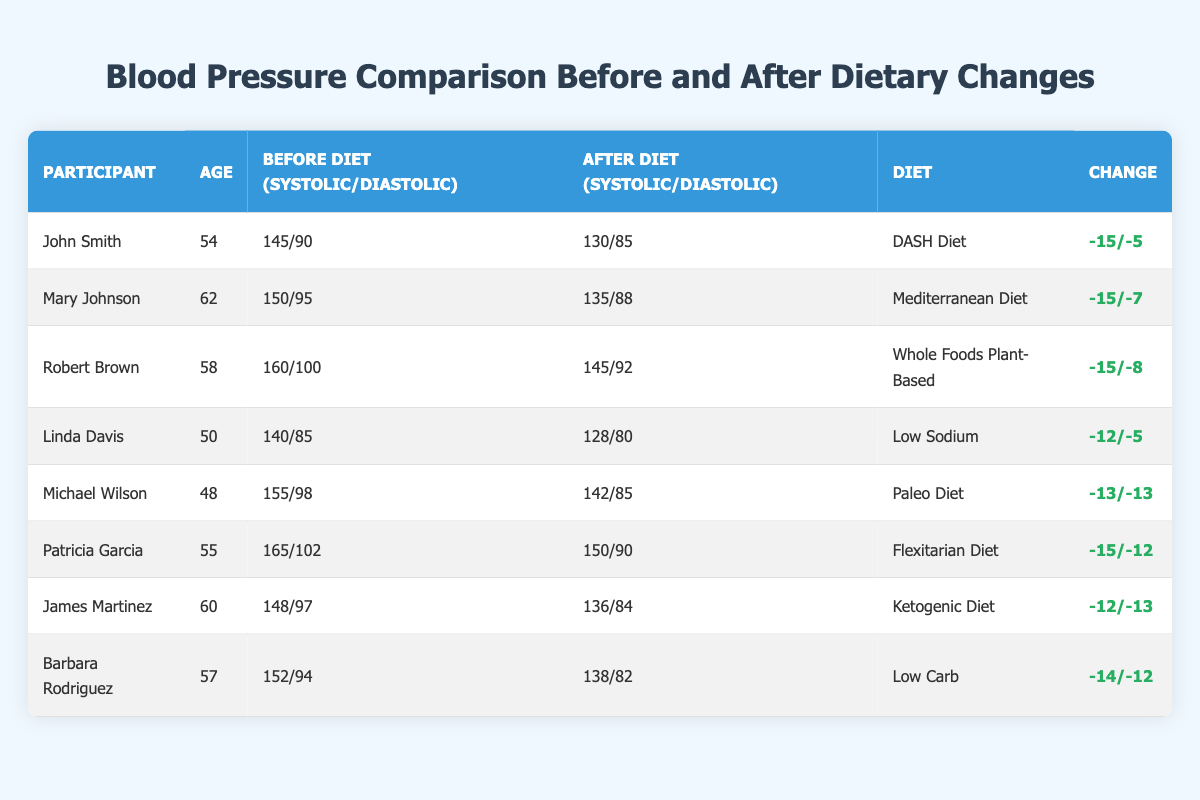What was John Smith's blood pressure before the diet? The table lists John's before diet blood pressure as 145 systolic and 90 diastolic.
Answer: 145/90 Which diet led to the most significant decrease in systolic blood pressure? Robert Brown, on the Whole Foods Plant-Based diet, had a decrease from 160 to 145, which is a change of -15. This decrease is the largest in the table.
Answer: Whole Foods Plant-Based Did Linda Davis experience an improvement in both systolic and diastolic blood pressure? Linda's systolic decreased from 140 to 128 and diastolic from 85 to 80, indicating improvements in both measurements.
Answer: Yes What is the average reduction in diastolic blood pressure for all participants? The diastolic changes are -5, -7, -8, -5, -13, -12, -13, and -12. Summing these gives -60, and dividing by 8 participants results in an average of -7.5.
Answer: -7.5 Which participant had the highest blood pressure after dietary changes? Looking at the "After Diet" column, Patricia Garcia has the highest reading of 150 systolic and 90 diastolic, which is the maximum in that section.
Answer: Patricia Garcia How many participants had a diastolic reading of 85 or higher after the diet? After the diet, 5 participants have diastolic readings of 85 or higher (Patricia, Robert, Michael, James, and Linda).
Answer: 5 What is the total systolic blood pressure reduction among all participants? The systolic reductions are -15, -15, -15, -12, -13, -15, -12, and -14. Summing these gives -111, which represents the total reduction in systolic blood pressure.
Answer: -111 Did any participant have the same diastolic reading before and after the diet? No participant has the same diastolic reading before and after the diet, all showed improvements.
Answer: No Which diet had participants with the lowest average systolic blood pressure after the dietary change? After analyzing the “After Diet” systolic readings, Linda Davis had 128, John Smith 130, and others higher than these, leading to the conclusion that Low Sodium had the lowest average.
Answer: Low Sodium What percentage of participants showed improvement in both systolic and diastolic blood pressure? All 8 participants improved their systolic and diastolic readings, leading to a percentage of 100%.
Answer: 100% 